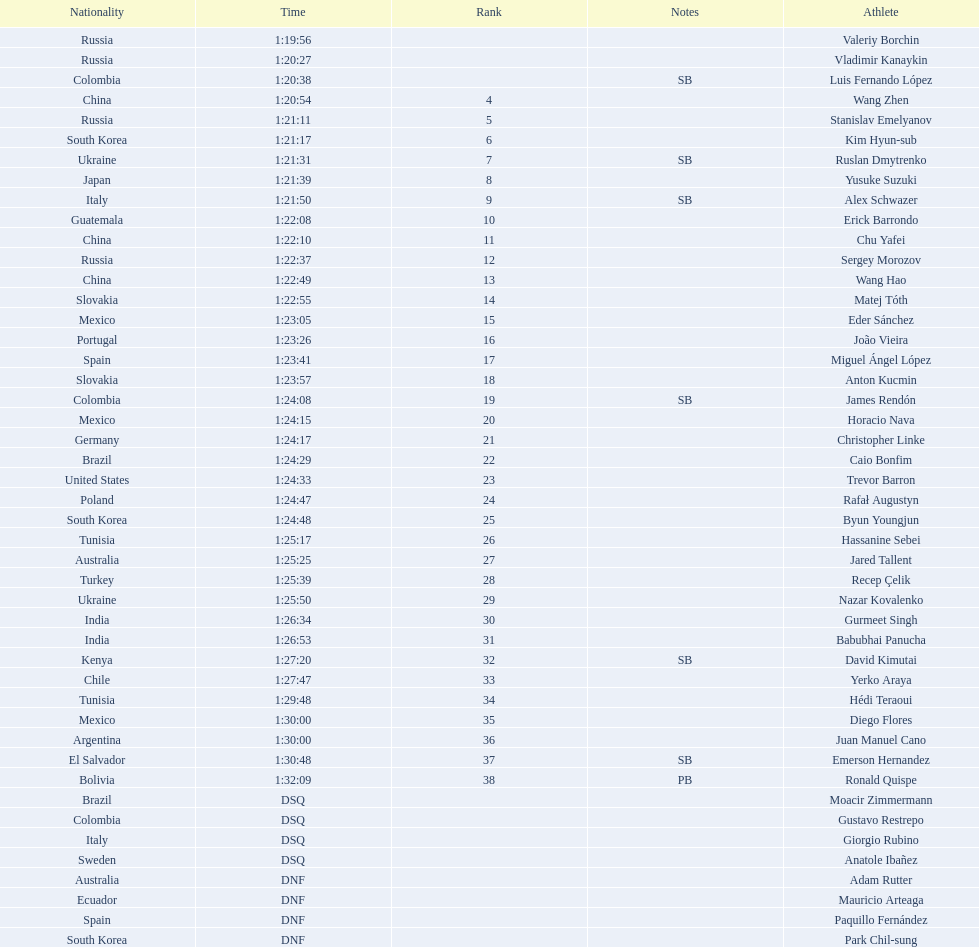Who placed in the top spot? Valeriy Borchin. 